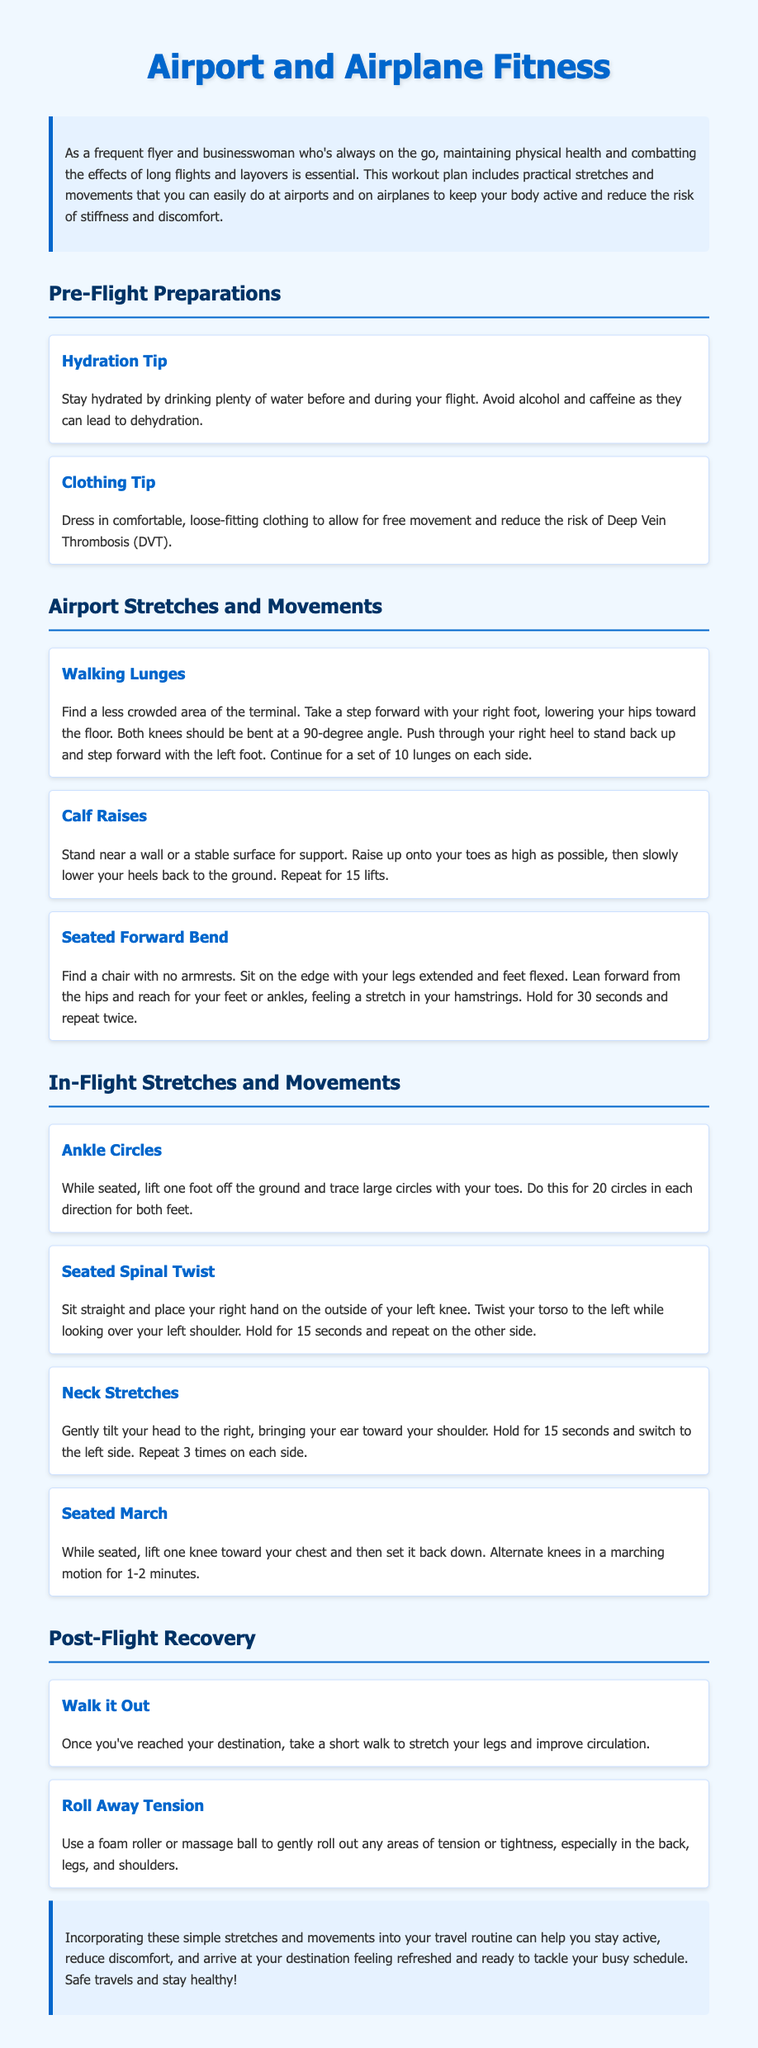What is the title of the document? The title is provided in the header of the document.
Answer: Airport and Airplane Fitness How many sets of walking lunges are recommended? The document specifies the number of lunges to perform for each side.
Answer: 10 lunges What stretch is suggested as a pre-flight preparation for hydration? This tip emphasizes the importance of hydration before and during the flight.
Answer: Stay hydrated How many neck stretches are recommended for each side? The document states how many times to repeat the neck stretch on each side.
Answer: 3 times What is the purpose of the seated spinal twist exercise? The document describes the action and intention behind this exercise.
Answer: Twist the torso What should you do after reaching your destination? The post-flight recovery tip outlines what to do after arriving.
Answer: Take a short walk What type of clothing is suggested to wear during flights? This tip addresses the type of clothing to wear to facilitate comfort and movement.
Answer: Comfortable, loose-fitting clothing Which exercise involves raising onto your toes? The description of the exercise identifies the main action performed.
Answer: Calf Raises 